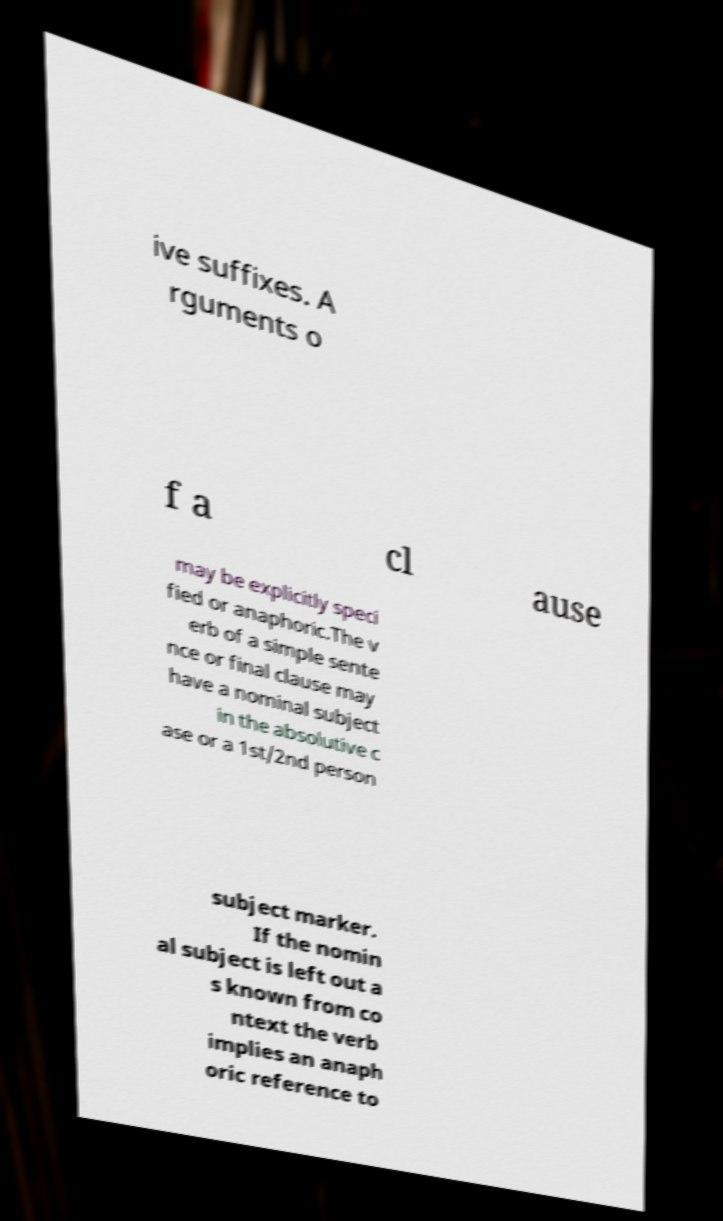Could you assist in decoding the text presented in this image and type it out clearly? ive suffixes. A rguments o f a cl ause may be explicitly speci fied or anaphoric.The v erb of a simple sente nce or final clause may have a nominal subject in the absolutive c ase or a 1st/2nd person subject marker. If the nomin al subject is left out a s known from co ntext the verb implies an anaph oric reference to 